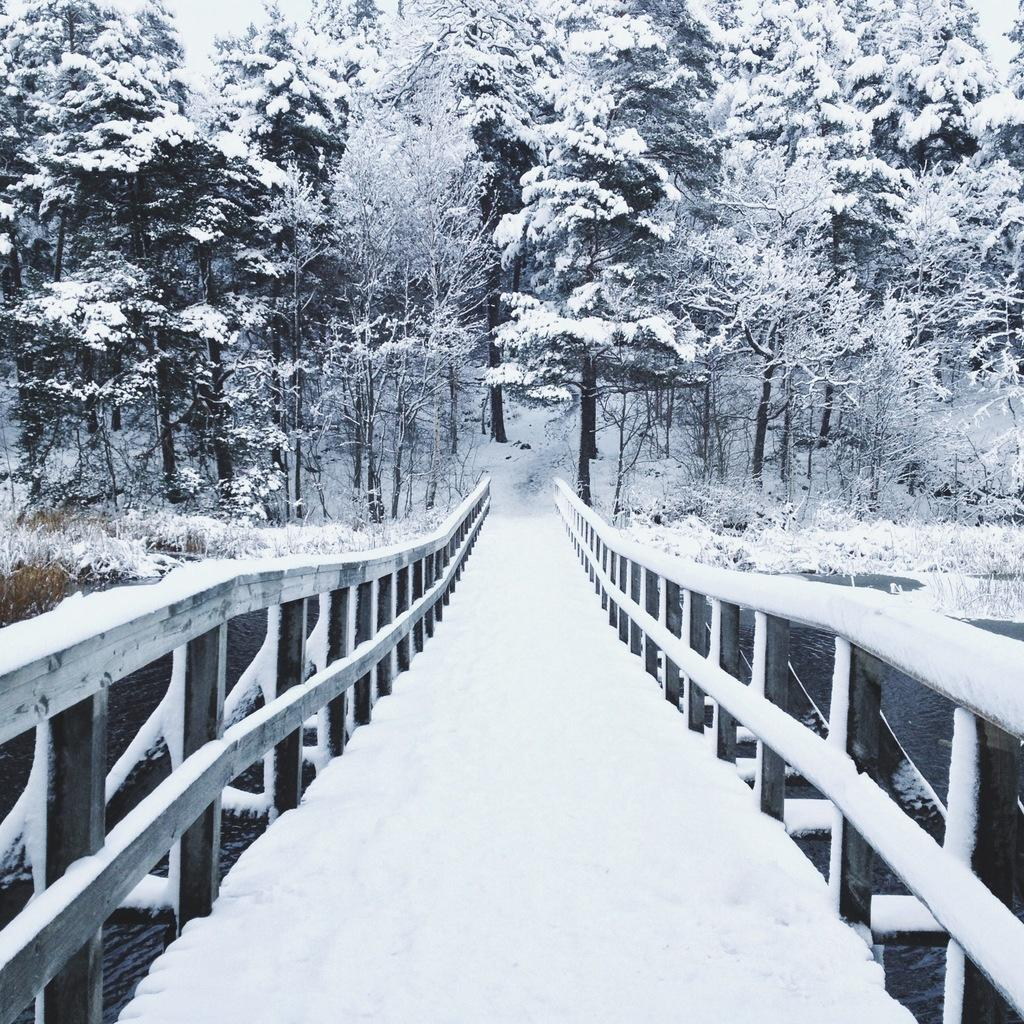What structure can be seen in the image? There is a bridge in the image. What is covering the bridge? The bridge has snow on it. What can be seen in the background of the image? There is a group of trees and plants in the background of the image. What natural element is visible in the background of the image? There is water visible in the background of the image. What type of sofa can be seen in the image? There is no sofa present in the image; it features a snow-covered bridge and a background with trees, plants, and water. What story is being told by the hammer in the image? There is no hammer present in the image, so no story can be told by it. 